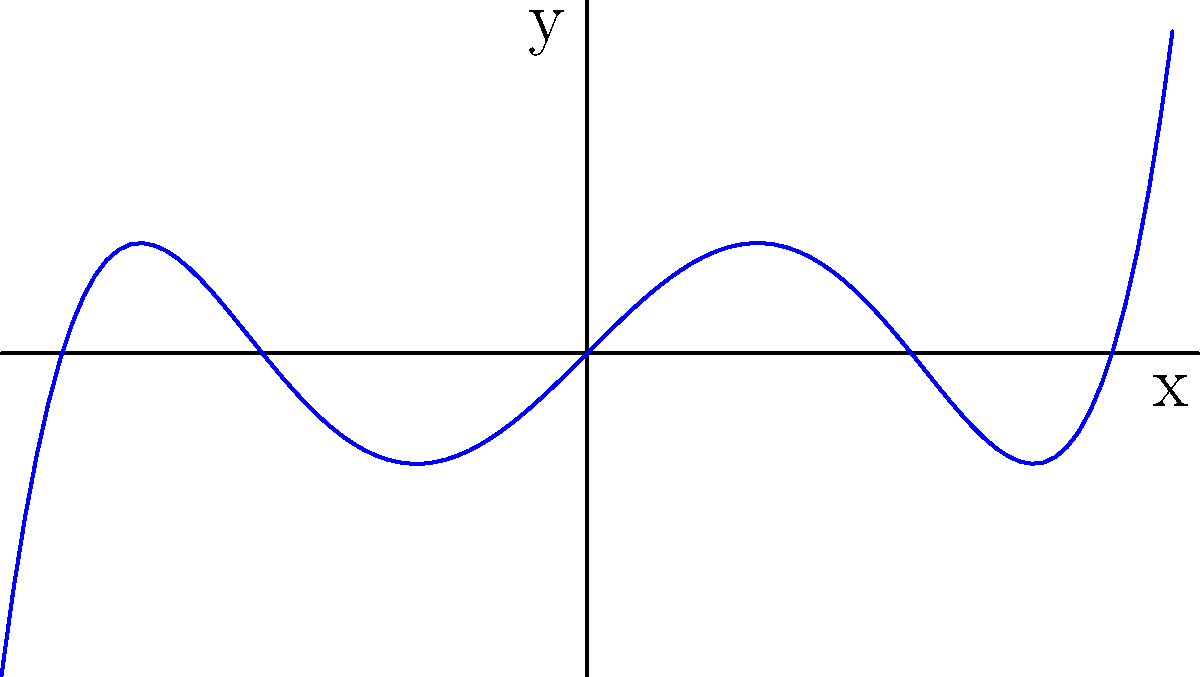As a forum moderator overseeing discussions on hacking and cybersecurity, you encounter a post about modeling network traffic patterns using polynomial functions. The graph above represents such a model. Based on the end behavior of this function, what is the degree of the polynomial and is it odd or even? To determine the degree and parity of the polynomial based on its end behavior, we need to follow these steps:

1. Observe the behavior of the function as $x$ approaches positive and negative infinity:
   - As $x \to +\infty$, $y \to +\infty$
   - As $x \to -\infty$, $y \to -\infty$

2. Determine the degree:
   - The function increases without bound in both directions, indicating an odd-degree polynomial of degree 3 or higher.

3. Determine if it's odd or even:
   - The function behaves differently on the left and right sides (negative on the left, positive on the right), which is characteristic of odd functions.

4. Confirm the degree:
   - The curve has multiple turning points, suggesting a degree higher than 3.
   - The overall shape and smoothness indicate a likely degree of 5.

5. Conclusion:
   - The polynomial is of degree 5 (odd degree).
   - It is an odd function due to its symmetry about the origin when rotated 180°.

In the context of network traffic modeling, this could represent a complex pattern with multiple peaks and troughs over time, with an overall increasing trend for large positive or negative values.
Answer: Degree 5, odd 